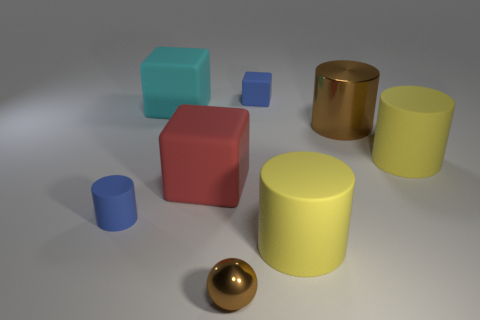Is there any other thing that has the same shape as the small brown metal thing?
Your answer should be very brief. No. Is the yellow cylinder that is in front of the small cylinder made of the same material as the large brown cylinder?
Ensure brevity in your answer.  No. What number of things are either gray rubber objects or large red rubber objects behind the small metallic thing?
Offer a very short reply. 1. There is a blue object that is the same shape as the red rubber thing; what is its size?
Offer a terse response. Small. Are there any blocks in front of the big cyan cube?
Provide a succinct answer. Yes. Is the color of the large cylinder that is on the left side of the brown metal cylinder the same as the large matte cylinder behind the big red rubber block?
Offer a terse response. Yes. Is there a blue object that has the same shape as the cyan matte thing?
Ensure brevity in your answer.  Yes. How many other things are there of the same color as the small cylinder?
Keep it short and to the point. 1. There is a big shiny thing that is to the right of the tiny blue cylinder that is on the left side of the cylinder to the right of the brown cylinder; what is its color?
Give a very brief answer. Brown. Are there the same number of tiny blue rubber cubes that are in front of the large red cube and tiny green rubber cylinders?
Make the answer very short. Yes. 